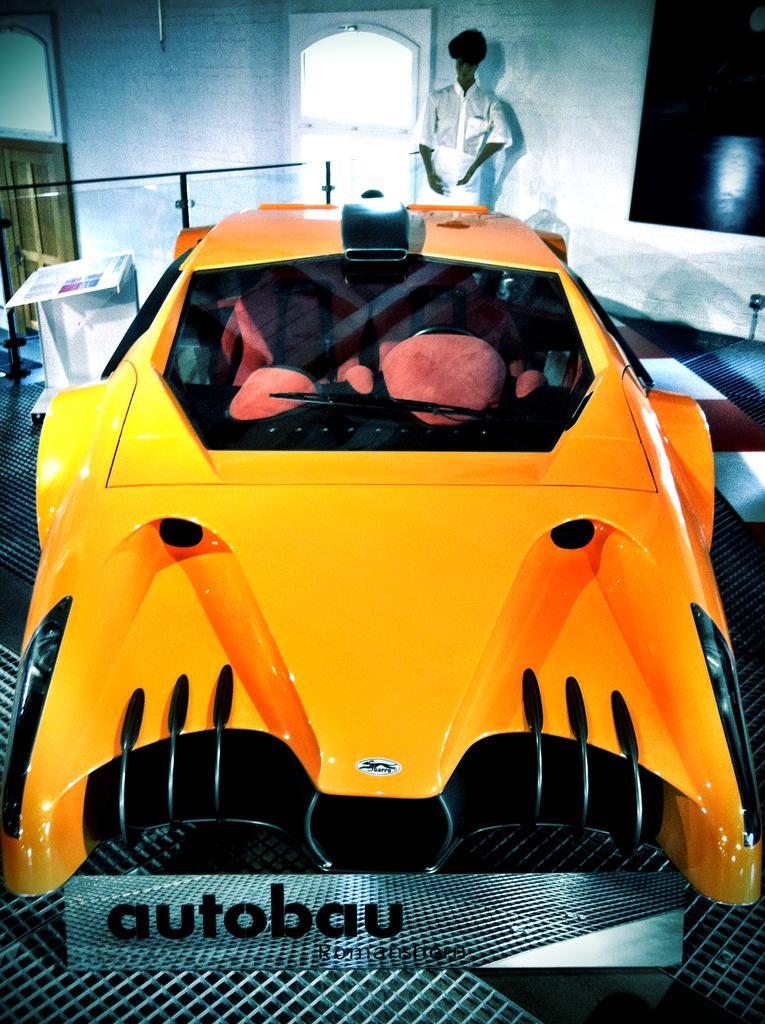Please provide a concise description of this image. In this picture there is a car in the center of the image and there is a door and a man at the top side of the image. 